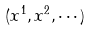Convert formula to latex. <formula><loc_0><loc_0><loc_500><loc_500>( x ^ { 1 } , x ^ { 2 } , \cdots )</formula> 